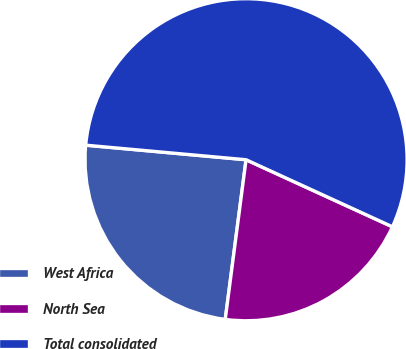Convert chart to OTSL. <chart><loc_0><loc_0><loc_500><loc_500><pie_chart><fcel>West Africa<fcel>North Sea<fcel>Total consolidated<nl><fcel>24.38%<fcel>20.23%<fcel>55.4%<nl></chart> 